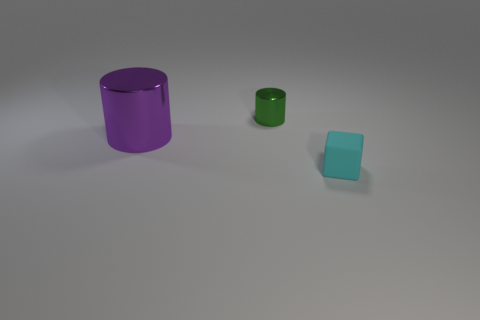Add 2 brown matte balls. How many objects exist? 5 Subtract all cylinders. How many objects are left? 1 Add 1 green metallic cylinders. How many green metallic cylinders exist? 2 Subtract 0 gray cylinders. How many objects are left? 3 Subtract all tiny objects. Subtract all tiny metal things. How many objects are left? 0 Add 3 large metallic objects. How many large metallic objects are left? 4 